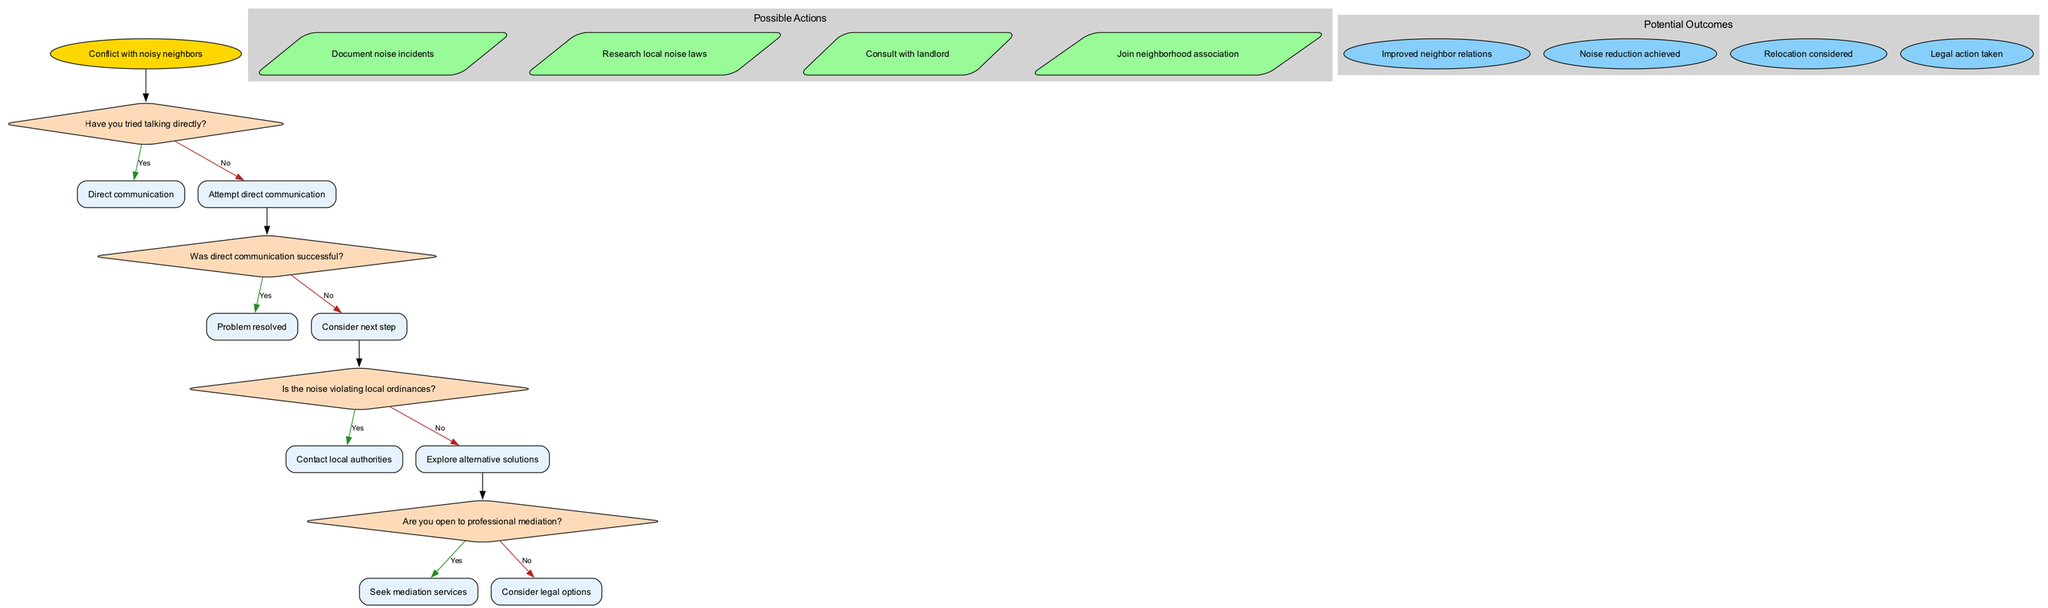What is the first decision question in the diagram? The first decision question is about whether direct communication has been tried. It's the initial question the flowchart poses to guide users.
Answer: Have you tried talking directly? What happens if direct communication is not successful? If direct communication fails, the flowchart suggests considering the next step. This indicates that the user should move forward to evaluate the noise's legality.
Answer: Consider next step How many potential outcomes are listed in the diagram? There are four potential outcomes displayed in the diagram, which represent the various endings of the conflict resolution process.
Answer: 4 What is the action suggested after considering local ordinances? If the noise is violating local ordinances, the next action is to contact local authorities. This step aims to involve regulatory bodies to address the issue.
Answer: Contact local authorities If the couple is not open to professional mediation, what does the flowchart suggest? If the couple is not open to professional mediation, they should consider legal options as an alternative route for conflict resolution. This suggests they might take more formal actions against the noise issue.
Answer: Consider legal options Which outcome corresponds to the scenario of improved neighbor relations? The outcome of improved neighbor relations is one of the potential results of successfully resolving the issue, indicating that communication and resolution efforts were effective.
Answer: Improved neighbor relations What is the relationship between the action "Research local noise laws" and the decision "Is the noise violating local ordinances?" The action "Research local noise laws" provides background information needed to help answer the decision question about whether the noise is indeed violating local ordinances, showing it as an informative action linked to that decision.
Answer: Informative action Which decision leads to seeking mediation services? The decision regarding the openness to professional mediation ("Are you open to professional mediation?") directly leads to the action of seeking mediation services if the answer is yes. This is a clear progression in the conflict resolution process.
Answer: Seek mediation services 